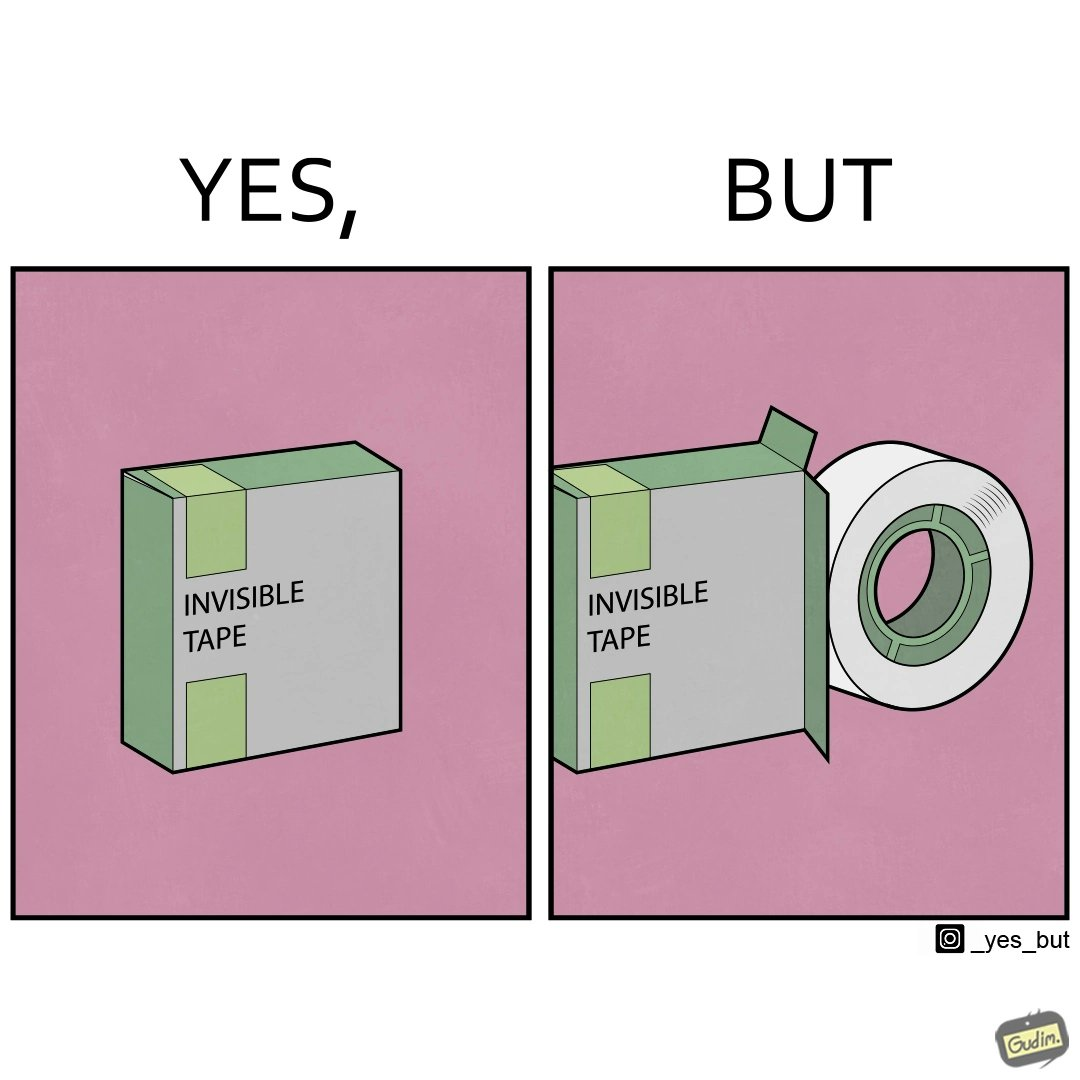What do you see in each half of this image? In the left part of the image: a pack of invisible tape. In the right part of the image: tape outside the 'invisible tape' pack. 